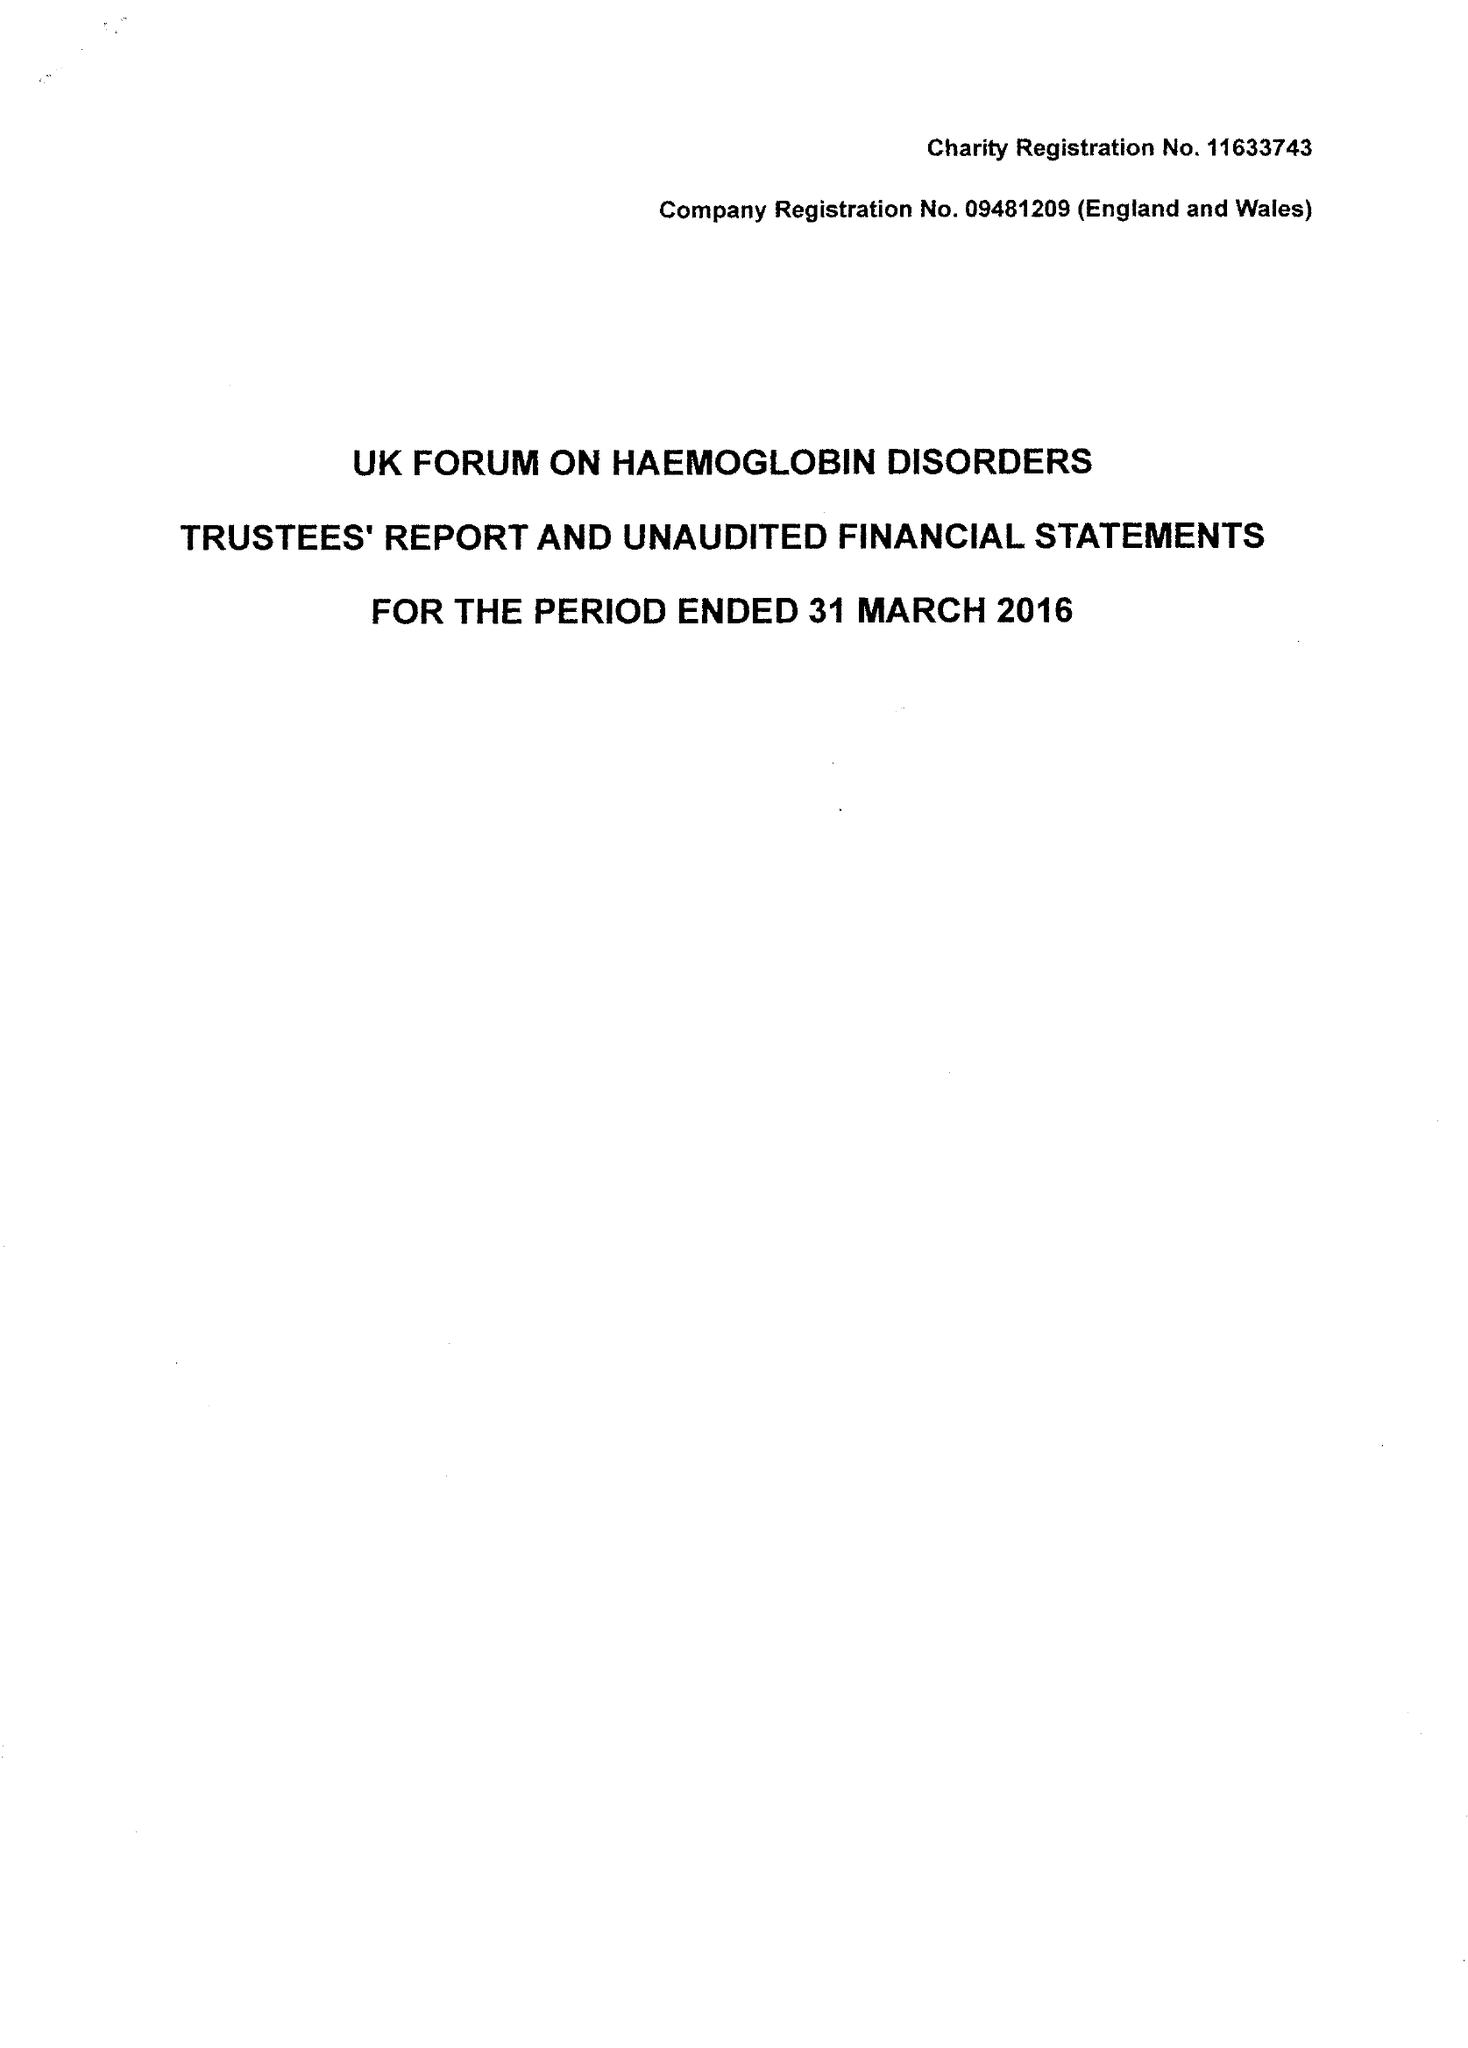What is the value for the income_annually_in_british_pounds?
Answer the question using a single word or phrase. 312062.00 